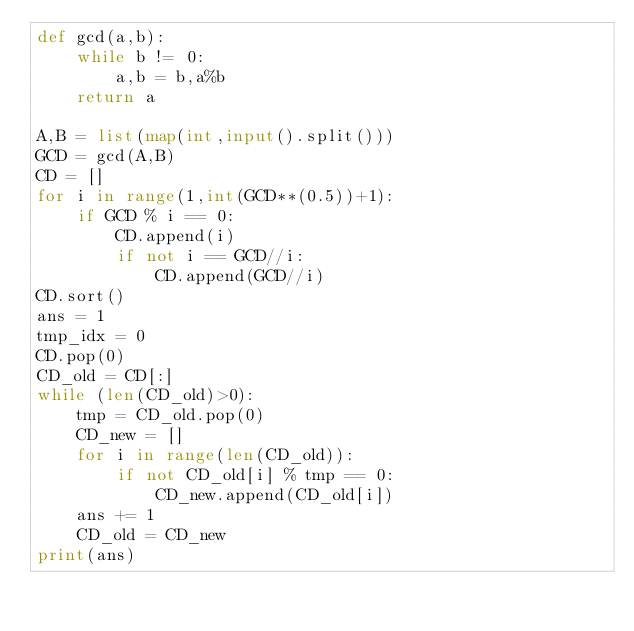<code> <loc_0><loc_0><loc_500><loc_500><_Python_>def gcd(a,b):
    while b != 0:
        a,b = b,a%b
    return a

A,B = list(map(int,input().split()))
GCD = gcd(A,B)
CD = []
for i in range(1,int(GCD**(0.5))+1):
    if GCD % i == 0:
        CD.append(i)
        if not i == GCD//i:
            CD.append(GCD//i)
CD.sort()
ans = 1
tmp_idx = 0
CD.pop(0)
CD_old = CD[:]
while (len(CD_old)>0):
    tmp = CD_old.pop(0)
    CD_new = []
    for i in range(len(CD_old)):
        if not CD_old[i] % tmp == 0:
            CD_new.append(CD_old[i])
    ans += 1
    CD_old = CD_new
print(ans)
</code> 